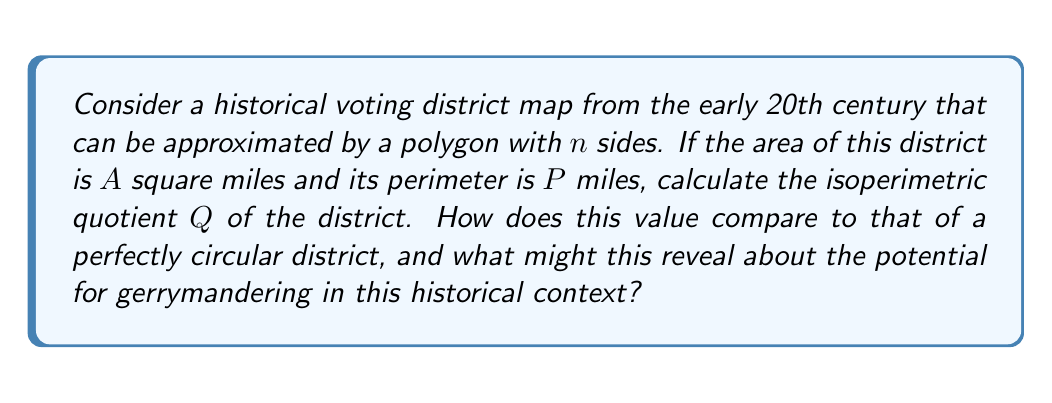Teach me how to tackle this problem. To solve this problem, we'll follow these steps:

1) The isoperimetric quotient $Q$ is defined as:

   $$Q = \frac{4\pi A}{P^2}$$

   where $A$ is the area and $P$ is the perimeter.

2) We're given $A$ and $P$, so we can directly substitute these values into the formula.

3) Calculate $Q$ using the given values of $A$ and $P$.

4) For a perfect circle, the isoperimetric quotient is always 1. This is because:
   
   For a circle: $A = \pi r^2$ and $P = 2\pi r$
   
   $$Q_{circle} = \frac{4\pi (\pi r^2)}{(2\pi r)^2} = \frac{4\pi^2 r^2}{4\pi^2 r^2} = 1$$

5) Compare the calculated $Q$ to 1:
   - If $Q$ is close to 1, the district is nearly circular.
   - If $Q$ is much smaller than 1, the district is highly irregular in shape.

6) In the context of gerrymandering:
   - A lower $Q$ value suggests a more irregularly shaped district, which could be an indicator of potential gerrymandering.
   - However, natural boundaries (rivers, mountains) can also lead to irregular shapes.
   - Historical context is crucial: early 20th century districting might reflect geographical or community boundaries more than modern gerrymandering practices.
Answer: $Q = \frac{4\pi A}{P^2}$; $Q < 1$ suggests irregular shape, potential gerrymandering; historical context crucial. 